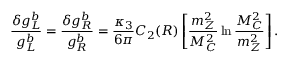<formula> <loc_0><loc_0><loc_500><loc_500>\frac { \delta g _ { L } ^ { b } } { g _ { L } ^ { b } } = \frac { \delta g _ { R } ^ { b } } { g _ { R } ^ { b } } = \frac { \kappa _ { 3 } } { 6 \pi } C _ { 2 } ( R ) \left [ \frac { m _ { Z } ^ { 2 } } { M _ { C } ^ { 2 } } \ln \frac { M _ { C } ^ { 2 } } { m _ { Z } ^ { 2 } } \right ] .</formula> 